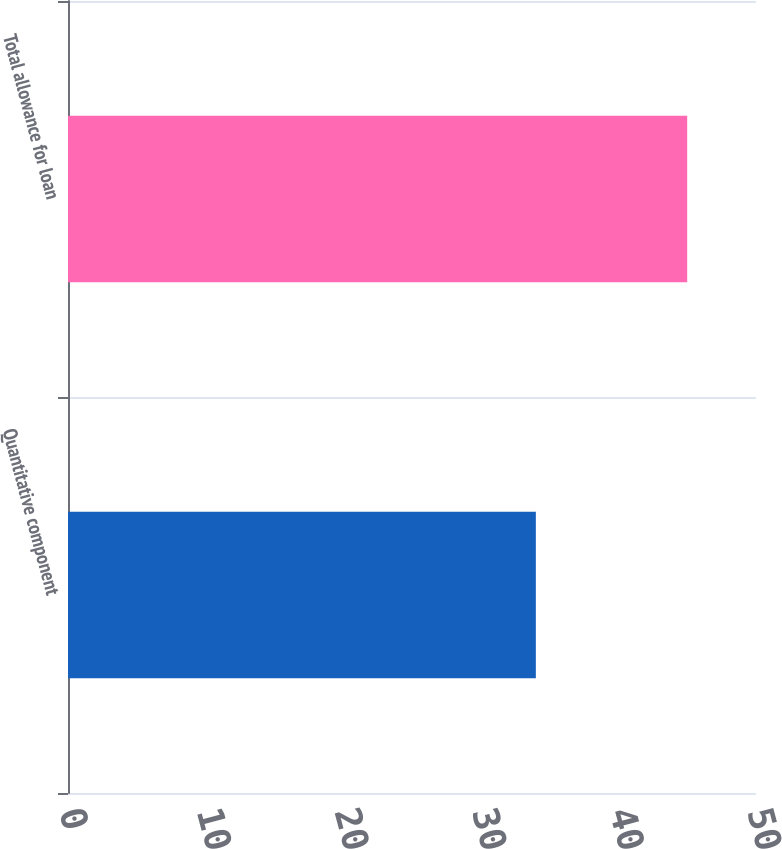Convert chart to OTSL. <chart><loc_0><loc_0><loc_500><loc_500><bar_chart><fcel>Quantitative component<fcel>Total allowance for loan<nl><fcel>34<fcel>45<nl></chart> 